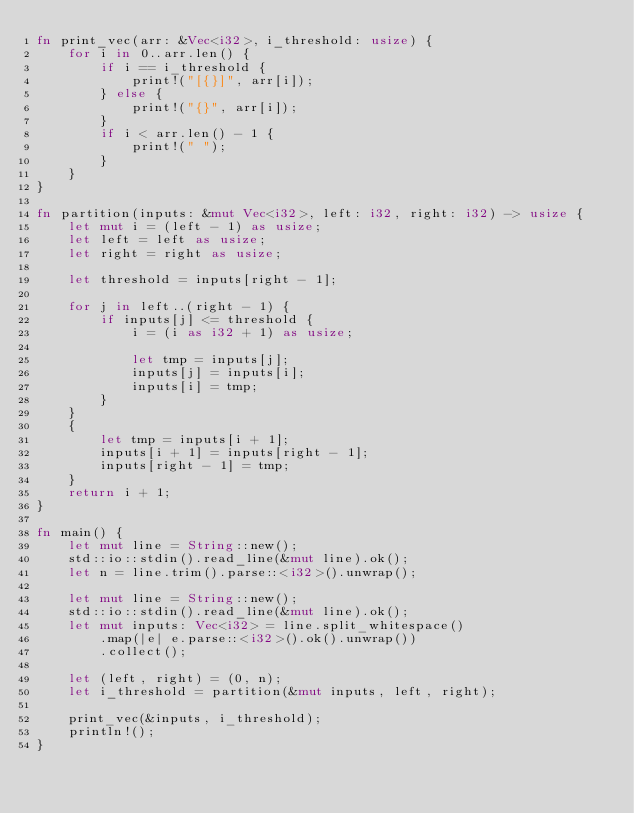<code> <loc_0><loc_0><loc_500><loc_500><_Rust_>fn print_vec(arr: &Vec<i32>, i_threshold: usize) {
    for i in 0..arr.len() {
        if i == i_threshold {
            print!("[{}]", arr[i]);
        } else {
            print!("{}", arr[i]);
        }
        if i < arr.len() - 1 {
            print!(" ");
        }
    }
}

fn partition(inputs: &mut Vec<i32>, left: i32, right: i32) -> usize {
    let mut i = (left - 1) as usize;
    let left = left as usize;
    let right = right as usize;

    let threshold = inputs[right - 1];

    for j in left..(right - 1) {
        if inputs[j] <= threshold {
            i = (i as i32 + 1) as usize;

            let tmp = inputs[j];
            inputs[j] = inputs[i];
            inputs[i] = tmp;
        }
    }
    {
        let tmp = inputs[i + 1];
        inputs[i + 1] = inputs[right - 1];
        inputs[right - 1] = tmp;
    }
    return i + 1;
}

fn main() {
    let mut line = String::new();
    std::io::stdin().read_line(&mut line).ok();
    let n = line.trim().parse::<i32>().unwrap();

    let mut line = String::new();
    std::io::stdin().read_line(&mut line).ok();
    let mut inputs: Vec<i32> = line.split_whitespace()
        .map(|e| e.parse::<i32>().ok().unwrap())
        .collect();

    let (left, right) = (0, n);
    let i_threshold = partition(&mut inputs, left, right);

    print_vec(&inputs, i_threshold);
    println!();
}

</code> 